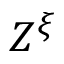<formula> <loc_0><loc_0><loc_500><loc_500>Z ^ { \xi }</formula> 